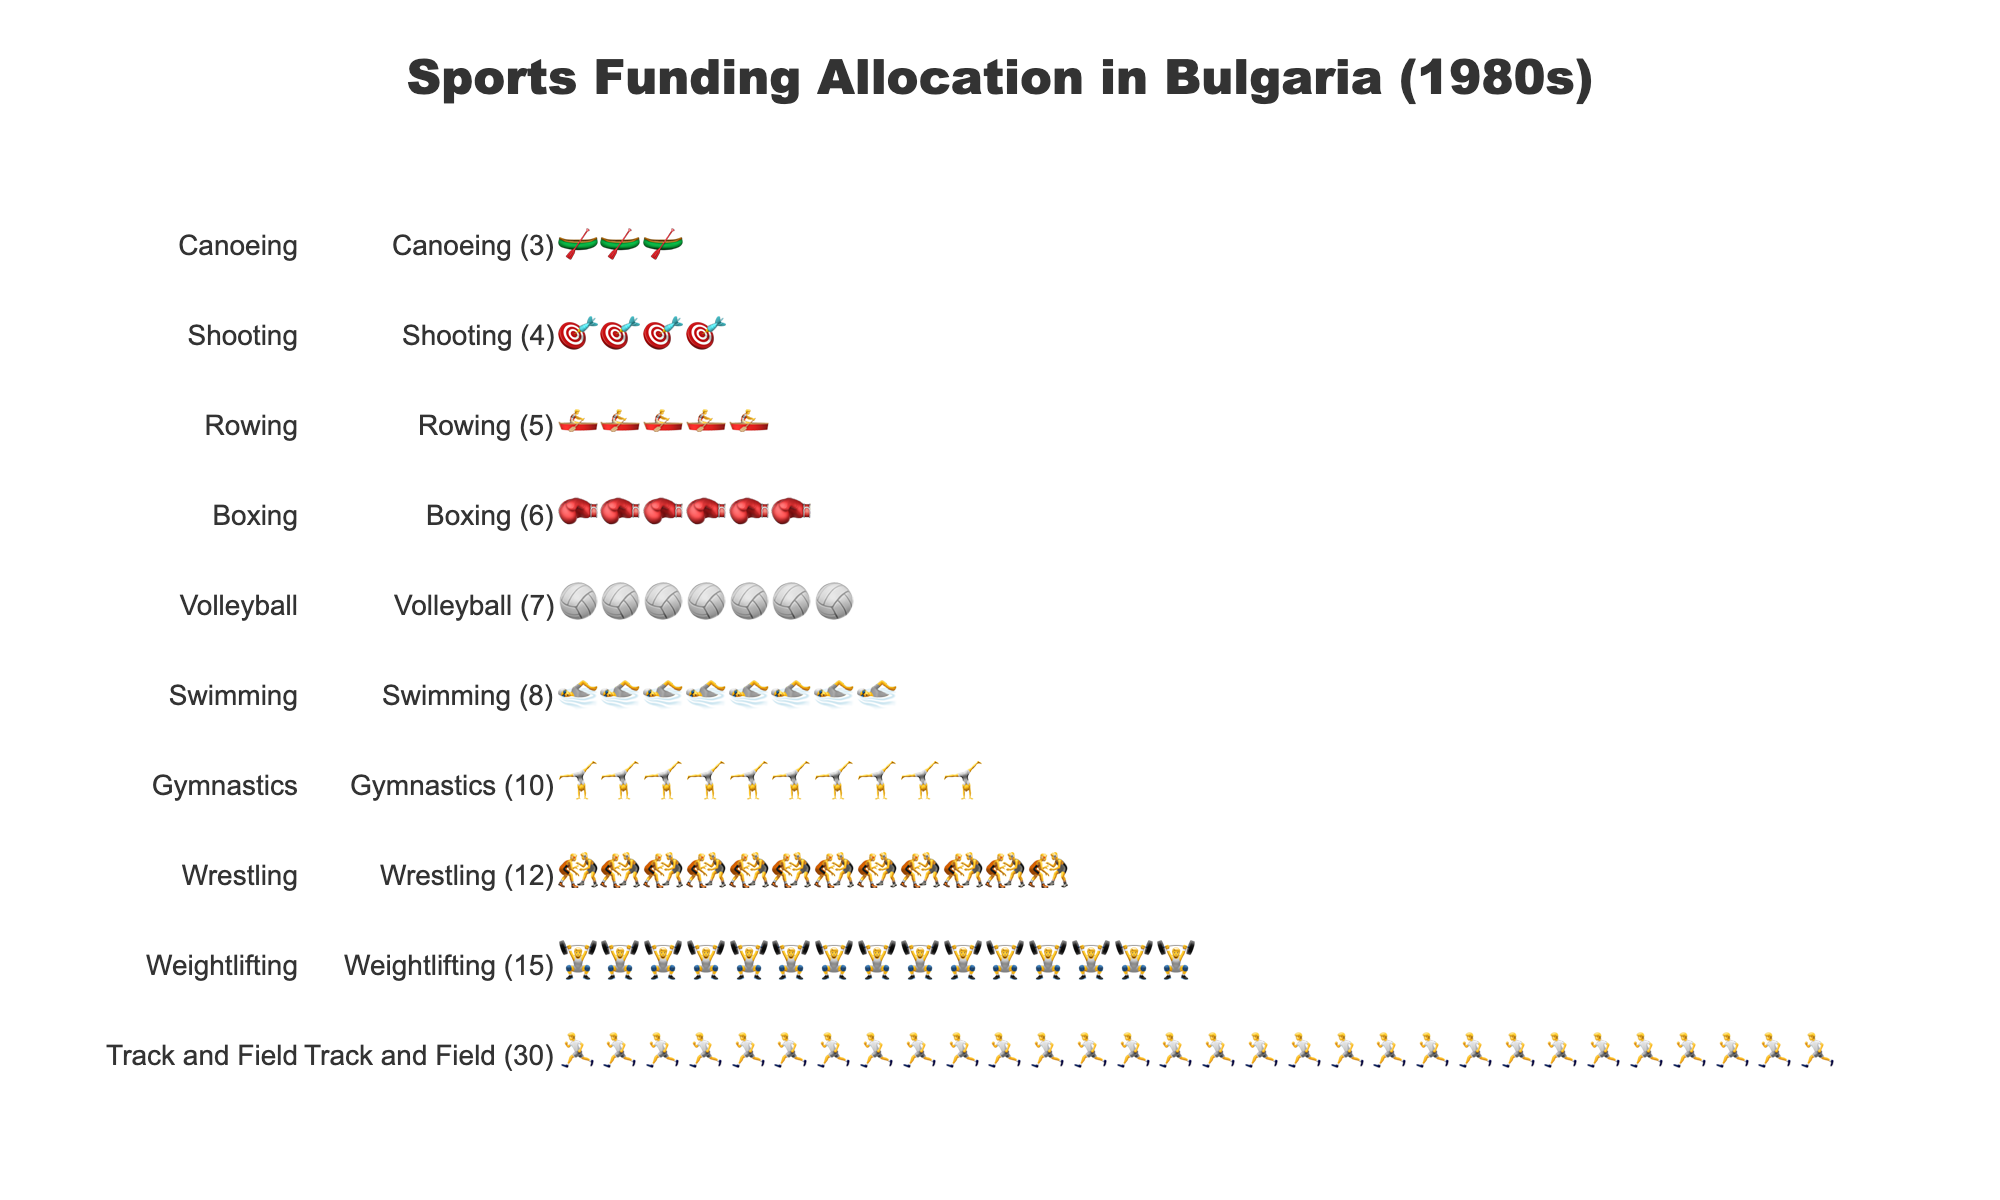Which sport received the most funding units? The sport with the greatest number of icons on the chart represents the most funding units. "Track and Field" has the most icons, indicating it received the most funding units.
Answer: Track and Field How many funding units were allocated to Gymnastics? To answer this, identify the row with the "🤸" icons. Count the number of these icons in the "Gymnastics" row to determine the funding units.
Answer: 10 Which sport received fewer funding units: Rowing or Canoeing? Compare the number of icons in the "Rowing" row (🚣) to the "Canoeing" row (🛶). Rowing has more icons than Canoeing.
Answer: Canoeing What is the difference in funding units between Weightlifting and Wrestling? Count the icons in the rows for Weightlifting (🏋️) and Wrestling (🤼). Subtract the number of icons for Wrestling from those for Weightlifting (15 - 12).
Answer: 3 How many total funding units were allocated to Swimming, Volleyball, and Boxing combined? Count the icons in each respective row: Swimming (🏊, 8), Volleyball (🏐, 7), and Boxing (🥊, 6). Sum the numbers: 8 + 7 + 6.
Answer: 21 Which three sports received the least amount of funding? Identify the rows with the fewest icons. The bottom three rows, indicating the least funding, are "Shooting" (🎯), "Canoeing" (🛶), and "Rowing" (🚣).
Answer: Shooting, Canoeing, Rowing How many times more funding units did Track and Field receive compared to Canoeing? Count the icons in the "Track and Field" row (30) and the "Canoeing" row (3). Divide the number of Track and Field icons by Canoeing icons (30 / 3).
Answer: 10 Which sport is ranked fourth in terms of funding units received? Rank the sports by the number of icons from most to least. The sport in the fourth position is "Gymnastics".
Answer: Gymnastics What is the total number of funding units allocated across all sports? Sum the number of icons in all the rows. Track and Field (30) + Weightlifting (15) + Wrestling (12) + Gymnastics (10) + Swimming (8) + Volleyball (7) + Boxing (6) + Rowing (5) + Shooting (4) + Canoeing (3).
Answer: 100 